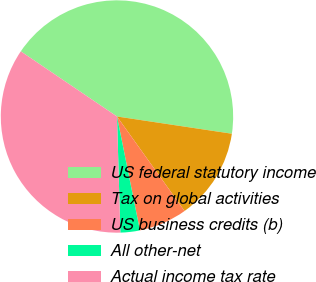<chart> <loc_0><loc_0><loc_500><loc_500><pie_chart><fcel>US federal statutory income<fcel>Tax on global activities<fcel>US business credits (b)<fcel>All other-net<fcel>Actual income tax rate<nl><fcel>42.9%<fcel>12.75%<fcel>6.72%<fcel>2.7%<fcel>34.94%<nl></chart> 